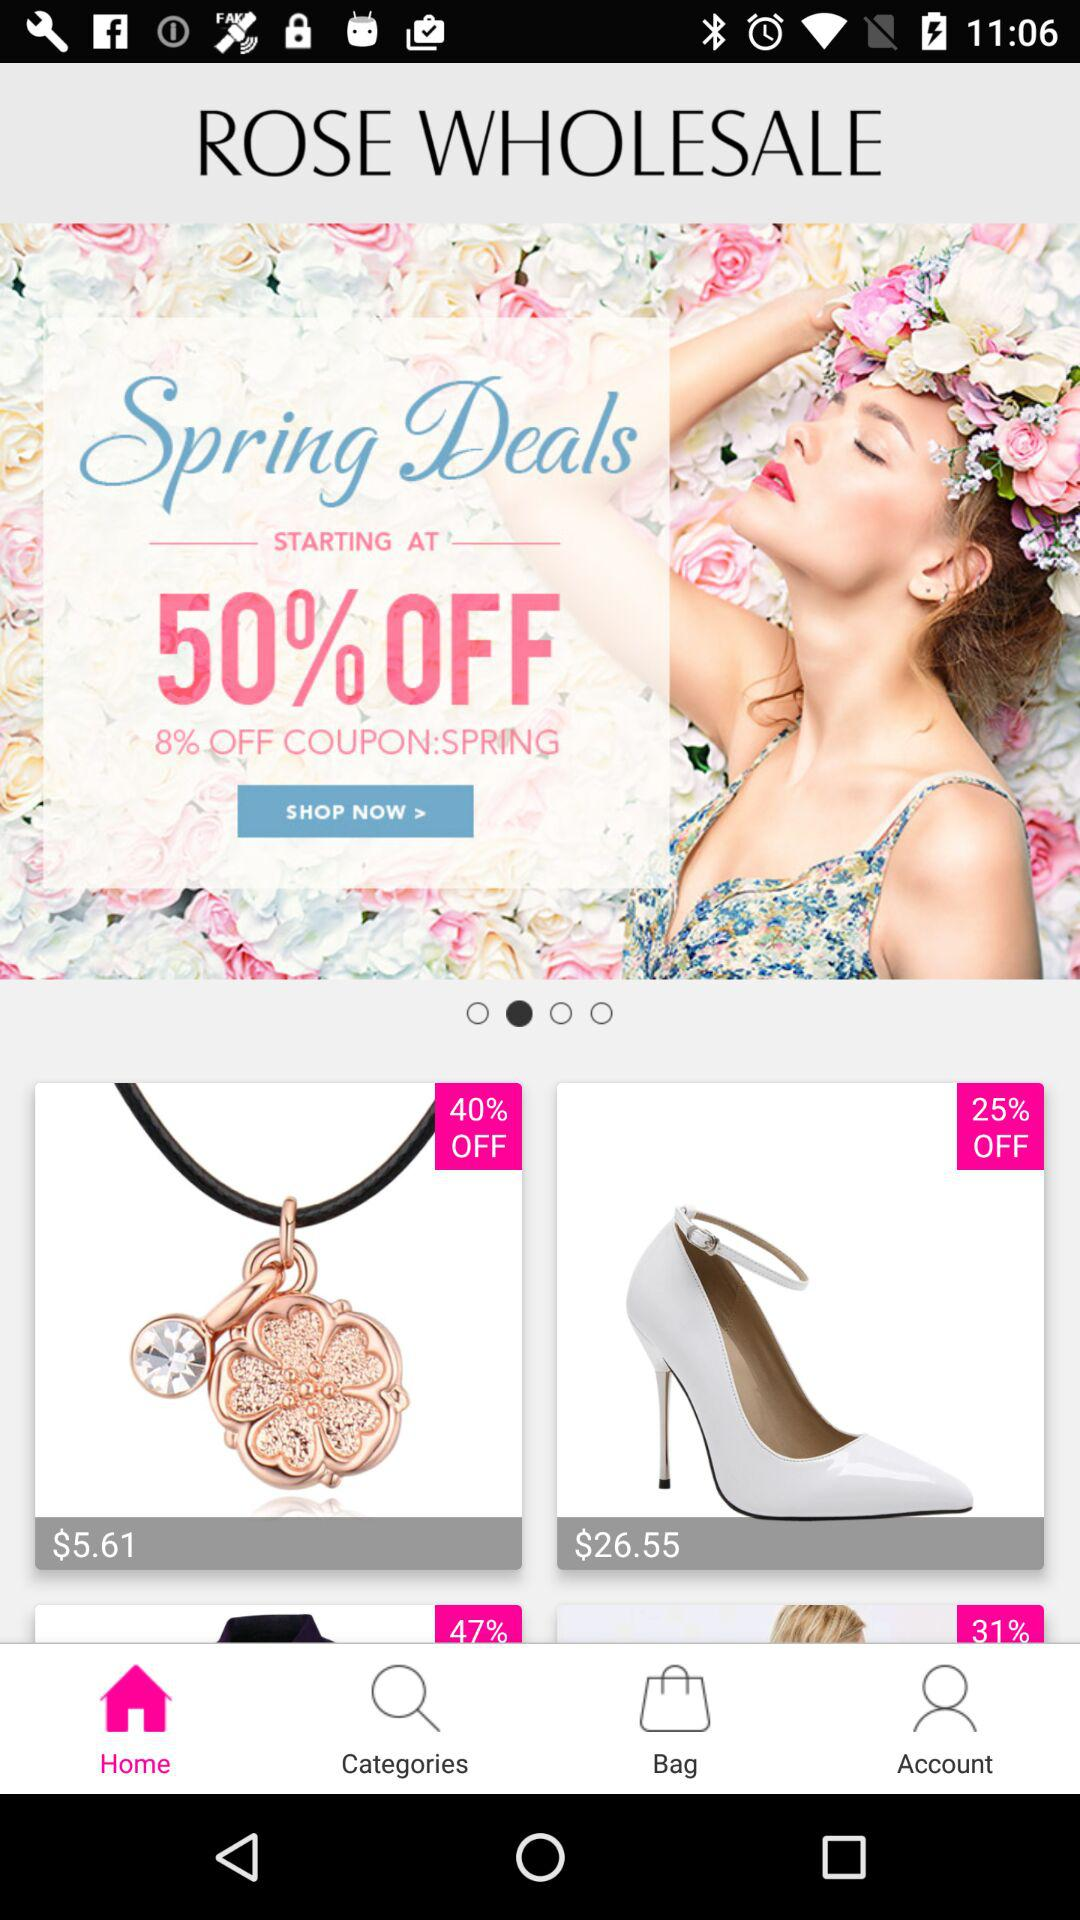How many items are on sale?
Answer the question using a single word or phrase. 4 